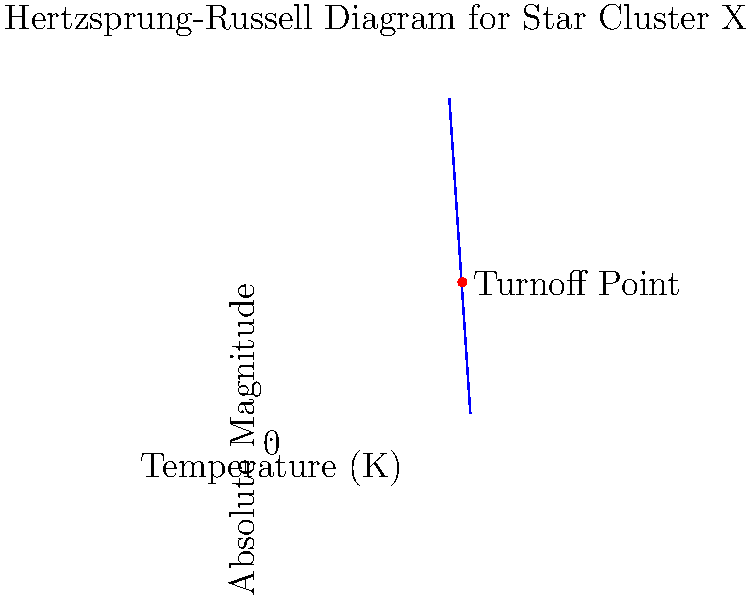Based on the Hertzsprung-Russell diagram shown for Star Cluster X, estimate the age of the cluster. Given that the temperature of the turnoff point is approximately 4470 K, and using the relation $t \approx \frac{10^{10}}{M^{2.5}}$ years (where $M$ is the mass of the star at the turnoff point in solar masses), what is the approximate age of the cluster? (Assume that the mass-luminosity relation for main sequence stars is $L \propto M^{3.5}$) To estimate the age of the star cluster, we'll follow these steps:

1) Identify the turnoff point on the H-R diagram. This is the point where stars are leaving the main sequence, marked in red.

2) The temperature of the turnoff point is given as 4470 K. We need to convert this to mass.

3) We can use the mass-luminosity relation for main sequence stars: $L \propto M^{3.5}$

4) At the turnoff point, we can approximate that $L \approx L_{\odot}$ and $T \approx 4470 K$. The Sun's temperature is about 5800 K.

5) Using Stefan-Boltzmann law, $L \propto R^2T^4$. Assuming the radius is similar to the Sun's at the turnoff point:

   $(\frac{4470}{5800})^4 \approx (\frac{M}{M_{\odot}})^{3.5}$

6) Solving this:
   $(\frac{4470}{5800})^{\frac{4}{3.5}} \approx \frac{M}{M_{\odot}} \approx 0.92$

7) Now we can use the given relation for age:
   $t \approx \frac{10^{10}}{M^{2.5}} = \frac{10^{10}}{(0.92)^{2.5}} \approx 1.2 \times 10^{10}$ years

Therefore, the estimated age of the cluster is approximately 12 billion years.
Answer: 12 billion years 